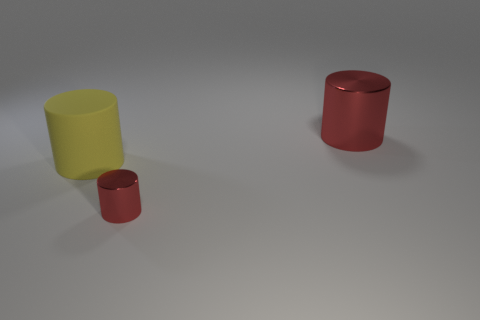Is there any other thing that is the same material as the yellow cylinder?
Your response must be concise. No. Are there any big red things of the same shape as the small red metal object?
Ensure brevity in your answer.  Yes. What is the shape of the thing that is both behind the small metal thing and on the right side of the large yellow rubber thing?
Offer a terse response. Cylinder. What number of other red cylinders have the same material as the big red cylinder?
Your answer should be compact. 1. Are there fewer metal things that are behind the small red object than big red cylinders?
Your answer should be compact. No. Are there any rubber cylinders that are behind the red object on the left side of the large red metallic thing?
Offer a very short reply. Yes. The red cylinder that is in front of the big thing to the left of the red metallic cylinder in front of the large yellow thing is made of what material?
Your response must be concise. Metal. Are there the same number of yellow cylinders on the left side of the large yellow rubber thing and big purple matte blocks?
Your answer should be very brief. Yes. How many objects are tiny red cylinders or cylinders?
Provide a short and direct response. 3. What is the shape of the large thing that is the same material as the small red cylinder?
Offer a very short reply. Cylinder. 